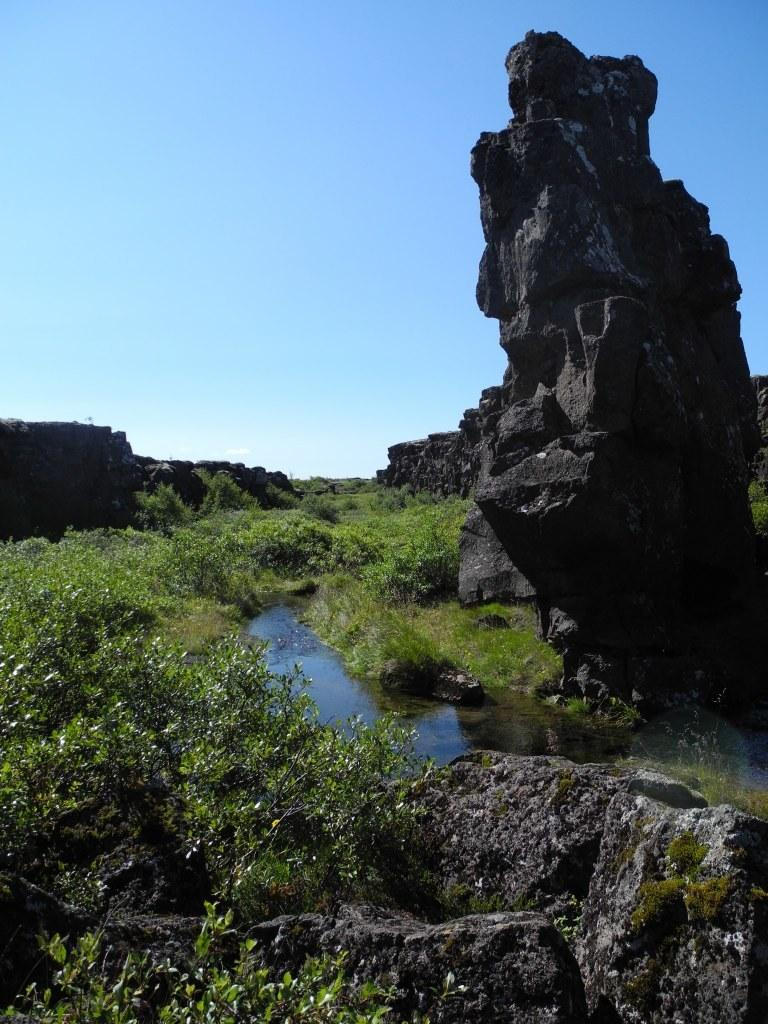What is the main feature at the center of the image? There is water at the center of the image. What can be seen at the front of the image? There are rocks at the front of the image. What type of vegetation is present on the surface of the image? There is grass on the surface of the image. What is visible in the background of the image? The sky is visible in the background of the image. What action is the rat performing in the image? There is no rat present in the image, so no action can be observed. 